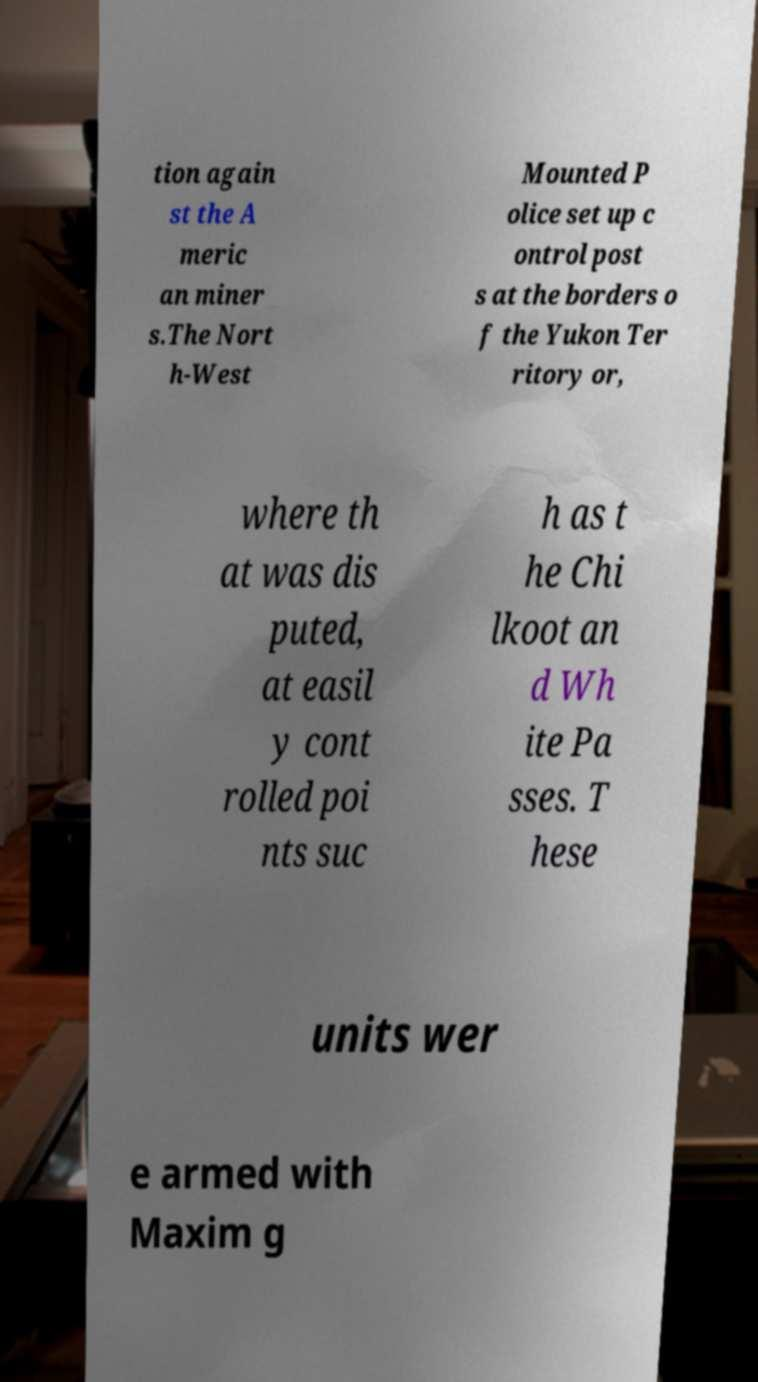Could you assist in decoding the text presented in this image and type it out clearly? tion again st the A meric an miner s.The Nort h-West Mounted P olice set up c ontrol post s at the borders o f the Yukon Ter ritory or, where th at was dis puted, at easil y cont rolled poi nts suc h as t he Chi lkoot an d Wh ite Pa sses. T hese units wer e armed with Maxim g 